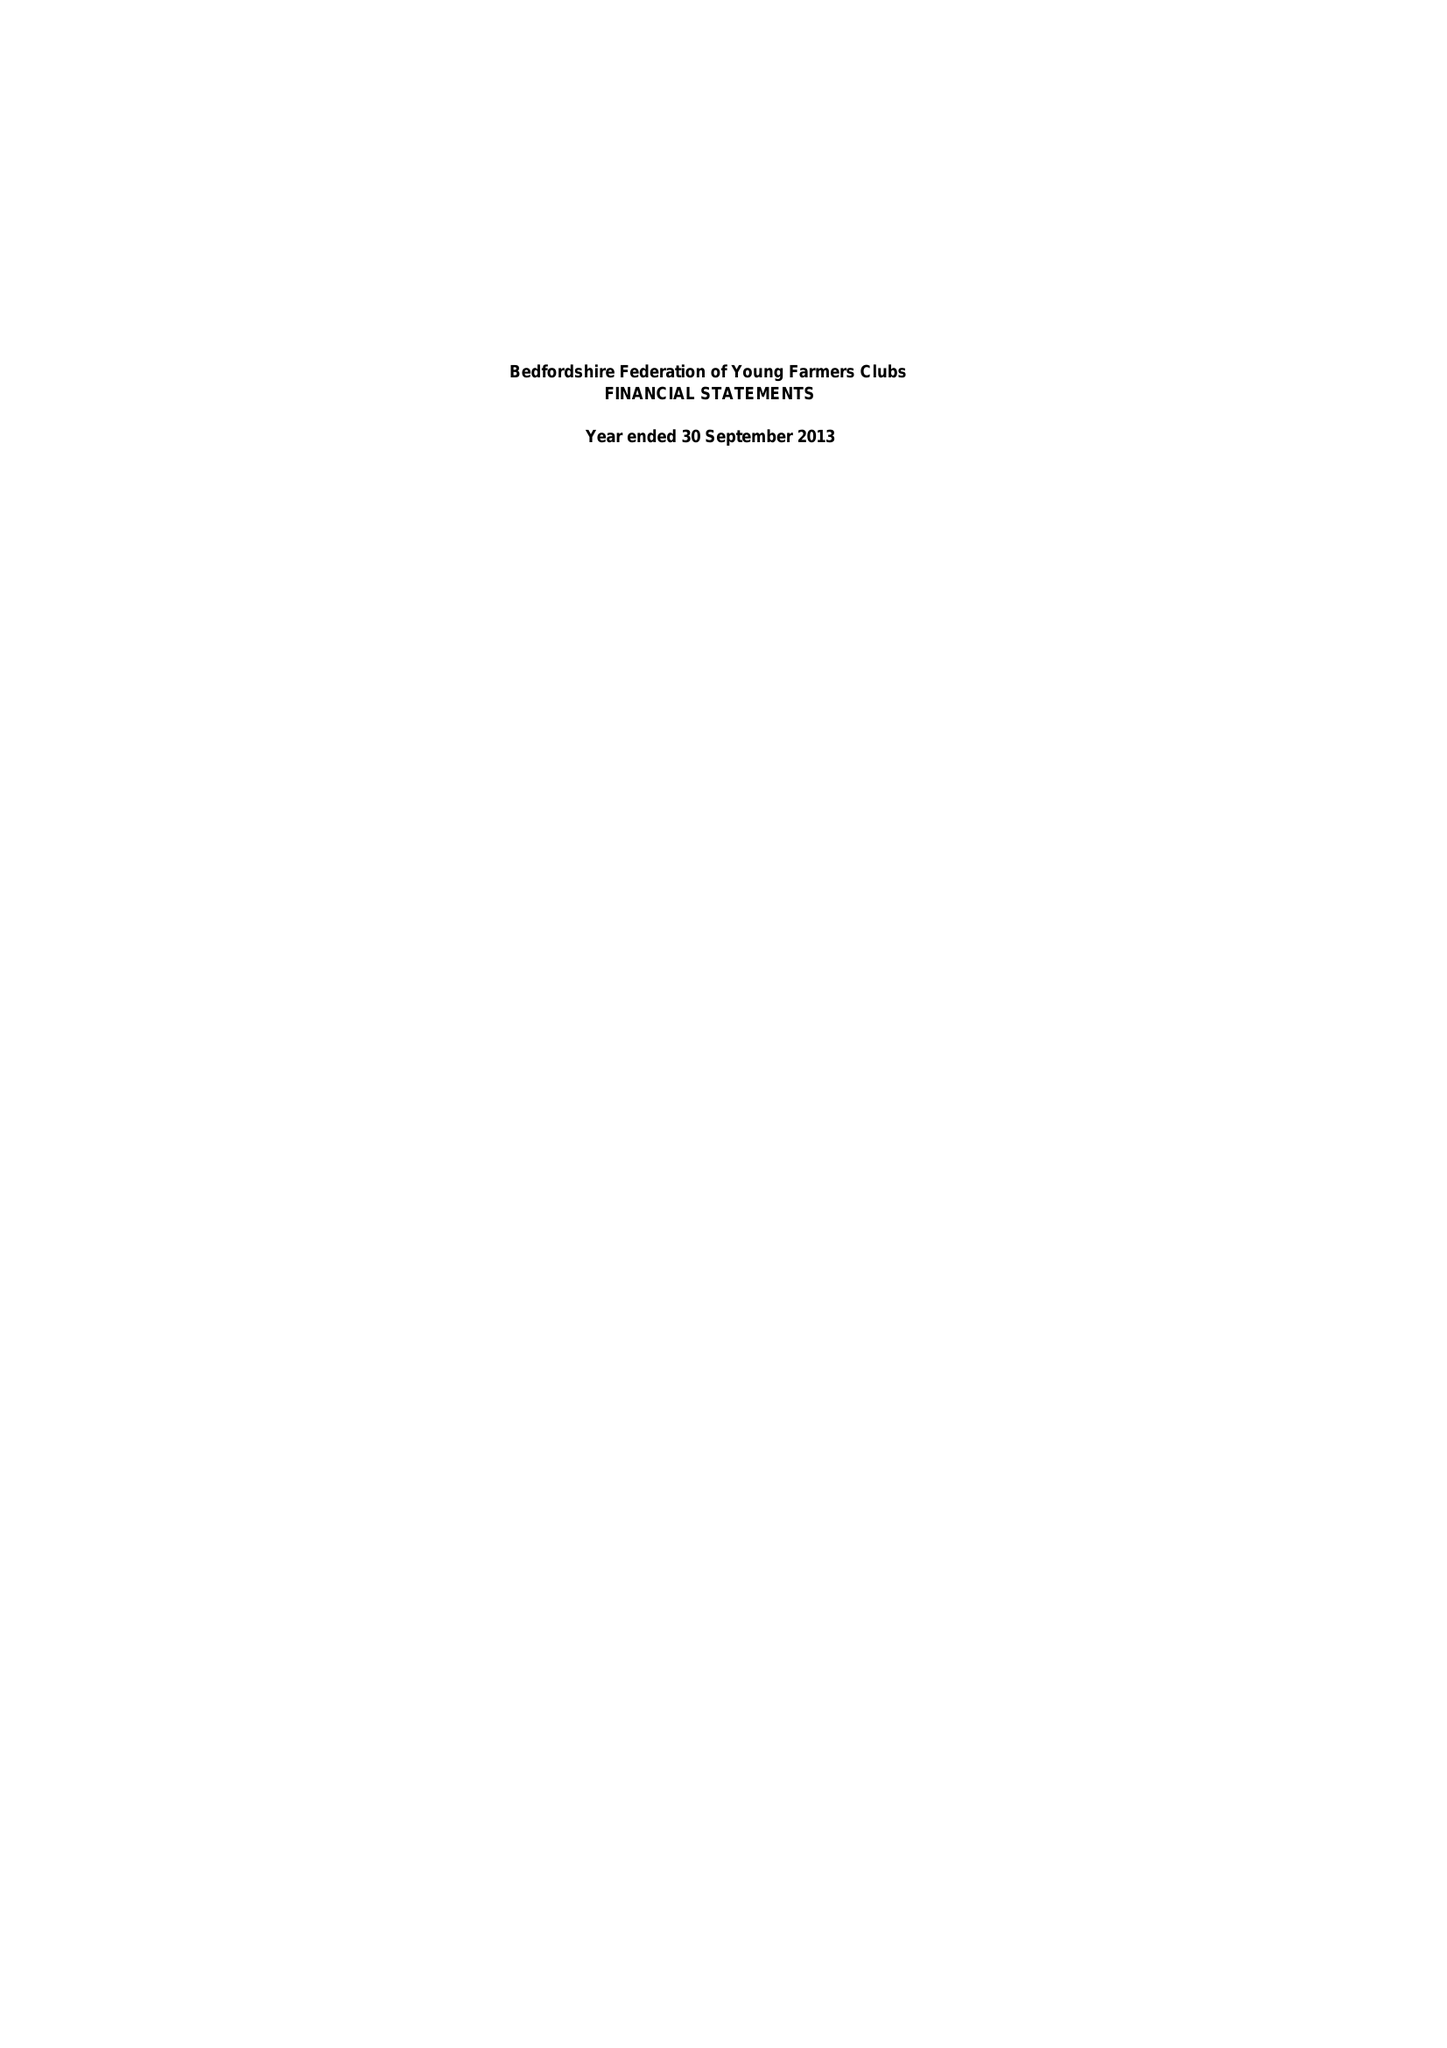What is the value for the charity_name?
Answer the question using a single word or phrase. Bedfordshire Federation Of Young Farmers Clubs 